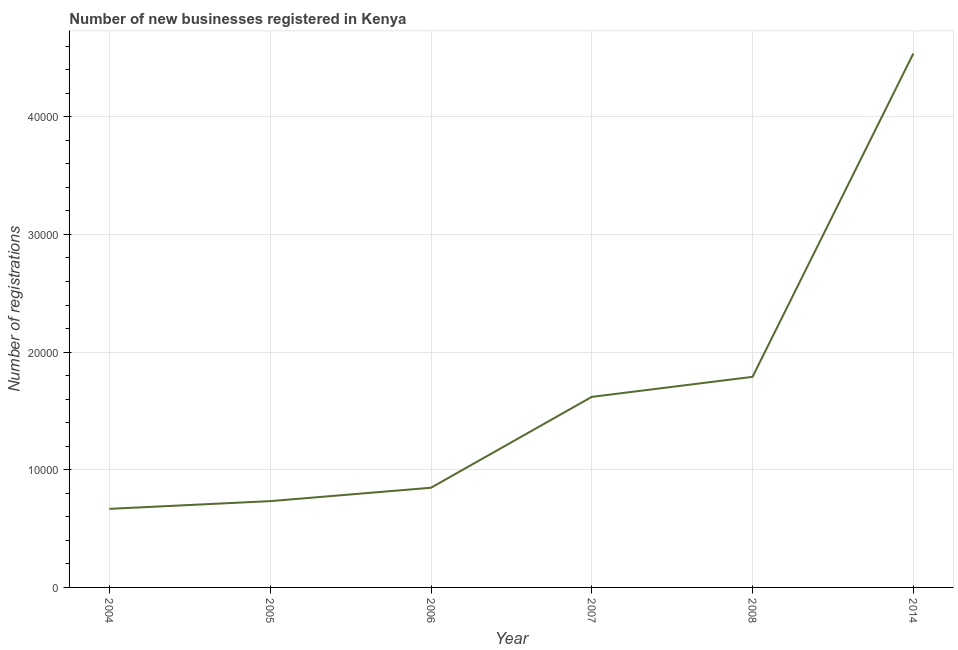What is the number of new business registrations in 2005?
Offer a very short reply. 7334. Across all years, what is the maximum number of new business registrations?
Your answer should be very brief. 4.54e+04. Across all years, what is the minimum number of new business registrations?
Offer a terse response. 6678. In which year was the number of new business registrations minimum?
Provide a short and direct response. 2004. What is the sum of the number of new business registrations?
Offer a very short reply. 1.02e+05. What is the difference between the number of new business registrations in 2007 and 2008?
Make the answer very short. -1703. What is the average number of new business registrations per year?
Offer a terse response. 1.70e+04. What is the median number of new business registrations?
Give a very brief answer. 1.23e+04. In how many years, is the number of new business registrations greater than 2000 ?
Your answer should be very brief. 6. Do a majority of the years between 2005 and 2014 (inclusive) have number of new business registrations greater than 12000 ?
Offer a terse response. Yes. What is the ratio of the number of new business registrations in 2007 to that in 2014?
Provide a succinct answer. 0.36. Is the number of new business registrations in 2004 less than that in 2007?
Provide a short and direct response. Yes. What is the difference between the highest and the second highest number of new business registrations?
Give a very brief answer. 2.75e+04. What is the difference between the highest and the lowest number of new business registrations?
Offer a very short reply. 3.87e+04. In how many years, is the number of new business registrations greater than the average number of new business registrations taken over all years?
Your answer should be very brief. 2. Does the number of new business registrations monotonically increase over the years?
Your answer should be very brief. Yes. What is the difference between two consecutive major ticks on the Y-axis?
Make the answer very short. 10000. Does the graph contain grids?
Offer a very short reply. Yes. What is the title of the graph?
Your answer should be very brief. Number of new businesses registered in Kenya. What is the label or title of the X-axis?
Offer a terse response. Year. What is the label or title of the Y-axis?
Your answer should be compact. Number of registrations. What is the Number of registrations in 2004?
Your response must be concise. 6678. What is the Number of registrations in 2005?
Make the answer very short. 7334. What is the Number of registrations in 2006?
Your answer should be compact. 8472. What is the Number of registrations of 2007?
Your answer should be very brief. 1.62e+04. What is the Number of registrations of 2008?
Keep it short and to the point. 1.79e+04. What is the Number of registrations in 2014?
Your response must be concise. 4.54e+04. What is the difference between the Number of registrations in 2004 and 2005?
Offer a very short reply. -656. What is the difference between the Number of registrations in 2004 and 2006?
Your answer should be compact. -1794. What is the difference between the Number of registrations in 2004 and 2007?
Provide a succinct answer. -9515. What is the difference between the Number of registrations in 2004 and 2008?
Offer a terse response. -1.12e+04. What is the difference between the Number of registrations in 2004 and 2014?
Ensure brevity in your answer.  -3.87e+04. What is the difference between the Number of registrations in 2005 and 2006?
Your response must be concise. -1138. What is the difference between the Number of registrations in 2005 and 2007?
Provide a short and direct response. -8859. What is the difference between the Number of registrations in 2005 and 2008?
Your answer should be compact. -1.06e+04. What is the difference between the Number of registrations in 2005 and 2014?
Ensure brevity in your answer.  -3.80e+04. What is the difference between the Number of registrations in 2006 and 2007?
Provide a short and direct response. -7721. What is the difference between the Number of registrations in 2006 and 2008?
Provide a succinct answer. -9424. What is the difference between the Number of registrations in 2006 and 2014?
Give a very brief answer. -3.69e+04. What is the difference between the Number of registrations in 2007 and 2008?
Keep it short and to the point. -1703. What is the difference between the Number of registrations in 2007 and 2014?
Offer a terse response. -2.92e+04. What is the difference between the Number of registrations in 2008 and 2014?
Make the answer very short. -2.75e+04. What is the ratio of the Number of registrations in 2004 to that in 2005?
Your answer should be very brief. 0.91. What is the ratio of the Number of registrations in 2004 to that in 2006?
Your answer should be very brief. 0.79. What is the ratio of the Number of registrations in 2004 to that in 2007?
Make the answer very short. 0.41. What is the ratio of the Number of registrations in 2004 to that in 2008?
Your response must be concise. 0.37. What is the ratio of the Number of registrations in 2004 to that in 2014?
Your response must be concise. 0.15. What is the ratio of the Number of registrations in 2005 to that in 2006?
Your answer should be compact. 0.87. What is the ratio of the Number of registrations in 2005 to that in 2007?
Your answer should be very brief. 0.45. What is the ratio of the Number of registrations in 2005 to that in 2008?
Your answer should be very brief. 0.41. What is the ratio of the Number of registrations in 2005 to that in 2014?
Give a very brief answer. 0.16. What is the ratio of the Number of registrations in 2006 to that in 2007?
Make the answer very short. 0.52. What is the ratio of the Number of registrations in 2006 to that in 2008?
Keep it short and to the point. 0.47. What is the ratio of the Number of registrations in 2006 to that in 2014?
Your response must be concise. 0.19. What is the ratio of the Number of registrations in 2007 to that in 2008?
Give a very brief answer. 0.91. What is the ratio of the Number of registrations in 2007 to that in 2014?
Your answer should be compact. 0.36. What is the ratio of the Number of registrations in 2008 to that in 2014?
Keep it short and to the point. 0.39. 